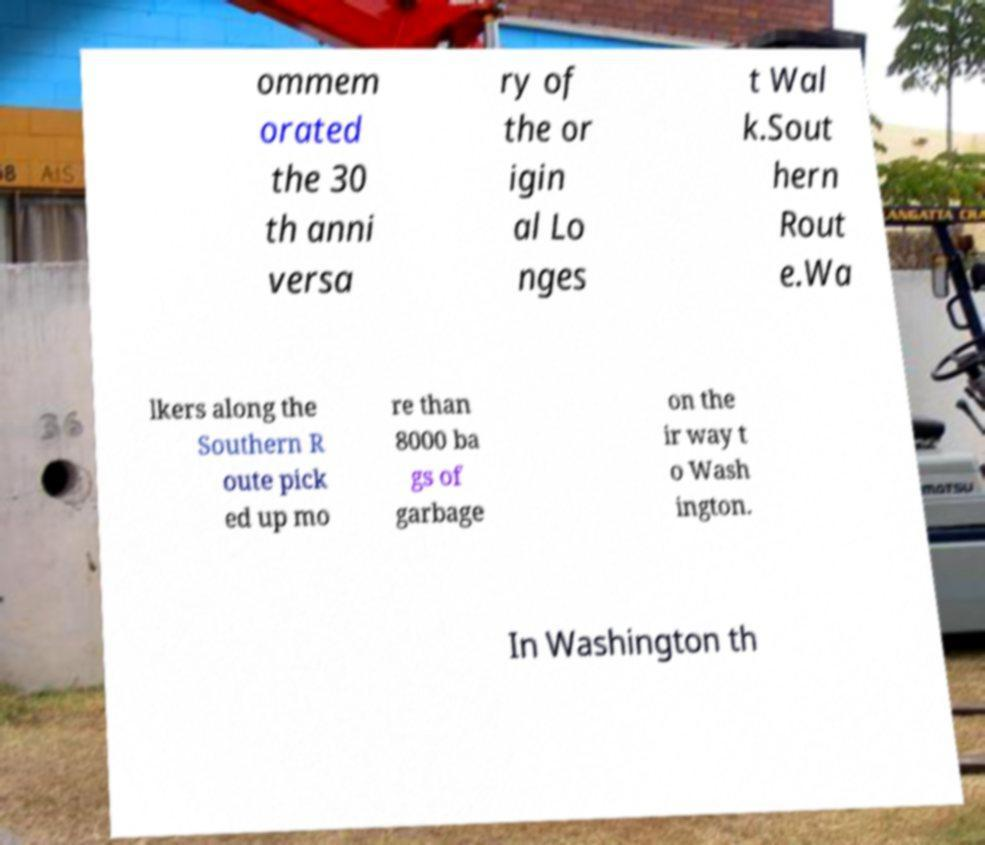Please identify and transcribe the text found in this image. ommem orated the 30 th anni versa ry of the or igin al Lo nges t Wal k.Sout hern Rout e.Wa lkers along the Southern R oute pick ed up mo re than 8000 ba gs of garbage on the ir way t o Wash ington. In Washington th 